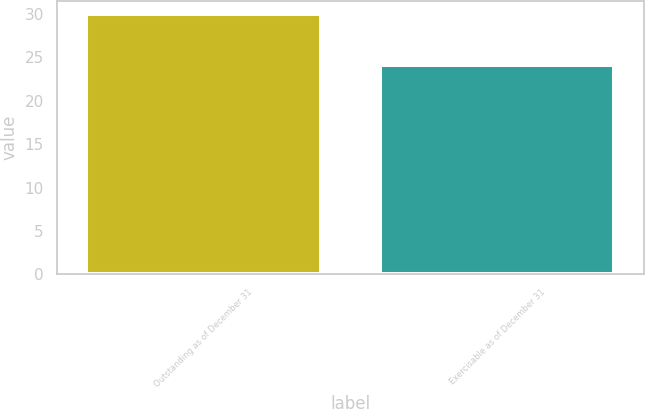Convert chart to OTSL. <chart><loc_0><loc_0><loc_500><loc_500><bar_chart><fcel>Outstanding as of December 31<fcel>Exercisable as of December 31<nl><fcel>29.99<fcel>24.1<nl></chart> 